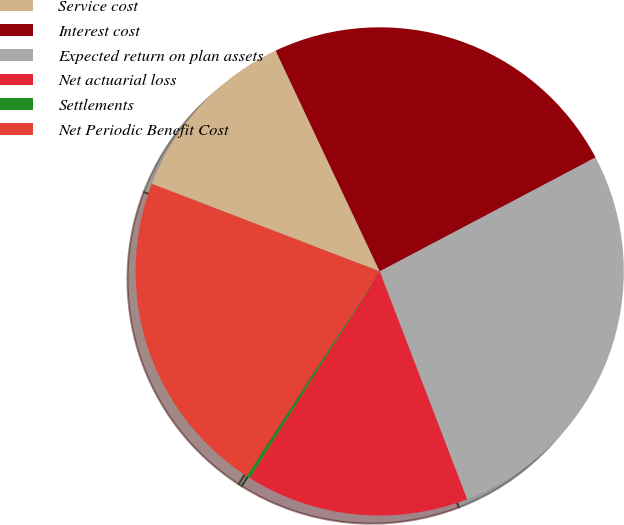Convert chart to OTSL. <chart><loc_0><loc_0><loc_500><loc_500><pie_chart><fcel>Service cost<fcel>Interest cost<fcel>Expected return on plan assets<fcel>Net actuarial loss<fcel>Settlements<fcel>Net Periodic Benefit Cost<nl><fcel>12.15%<fcel>24.28%<fcel>26.9%<fcel>14.76%<fcel>0.24%<fcel>21.67%<nl></chart> 